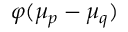<formula> <loc_0><loc_0><loc_500><loc_500>\varphi ( \mu _ { p } - \mu _ { q } )</formula> 